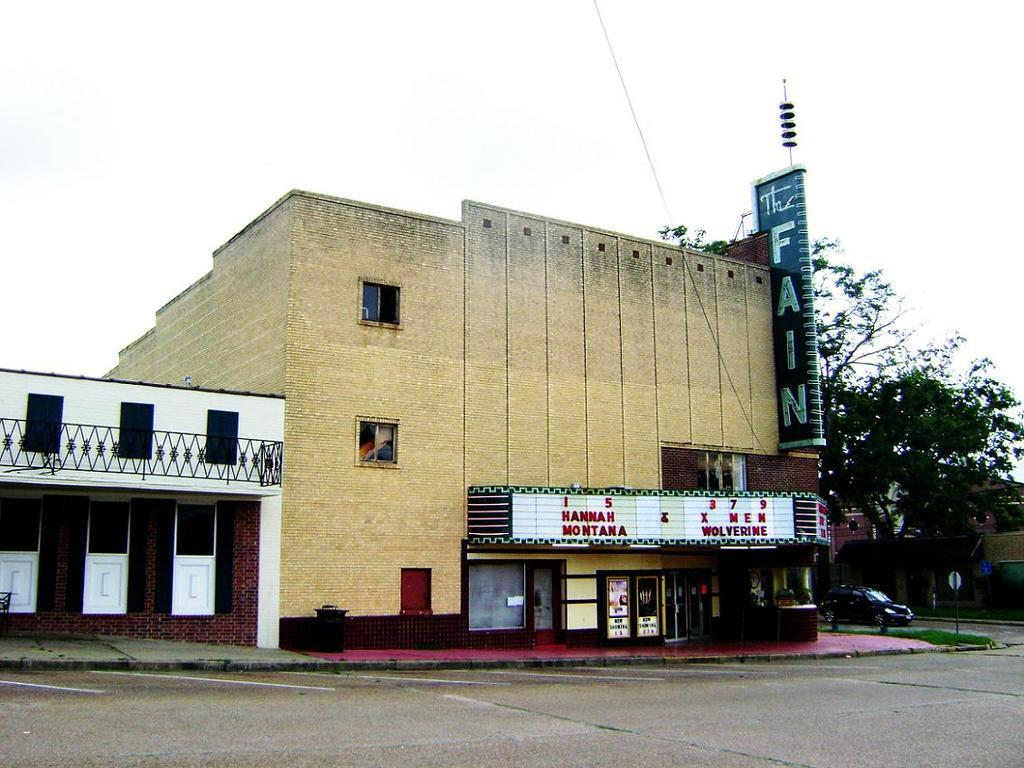What type of structures can be seen in the image? There are buildings in the image. What is the purpose of the fence in the image? The purpose of the fence in the image is to provide a barrier or boundary. What architectural features are visible on the buildings? Windows and doors are visible on the buildings in the image. What additional object is present in the image? There is a banner in the image. What type of vegetation is present in the image? There are trees in the image. What mode of transportation is visible in the image? There is a car in the image. What part of the natural environment is visible in the image? The sky is visible in the image. Can you tell me how many degrees the mountain in the image is tilted? There is no mountain present in the image; it features buildings, a fence, windows, doors, a banner, trees, a car, and the sky. What type of bait is being used to catch fish in the image? There is no fishing or bait present in the image. 